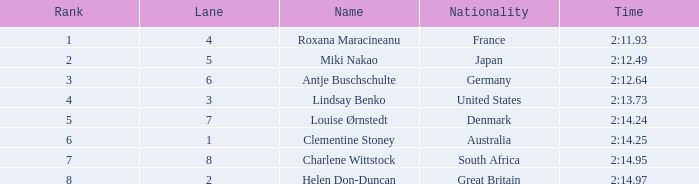95 is given? South Africa. 